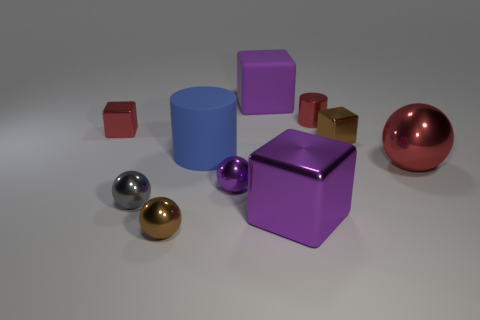Is the number of gray metal things that are to the left of the matte cylinder the same as the number of big metallic objects that are behind the tiny purple ball?
Offer a very short reply. Yes. There is a metal cube that is both behind the large blue object and in front of the small red metallic block; what is its color?
Your response must be concise. Brown. What is the material of the small cube that is to the right of the large purple block that is behind the large purple metal object?
Give a very brief answer. Metal. Does the matte cylinder have the same size as the red metal block?
Give a very brief answer. No. How many small things are red metallic cubes or purple matte things?
Offer a very short reply. 1. What number of small spheres are behind the big purple rubber cube?
Provide a short and direct response. 0. Is the number of big matte cylinders that are to the right of the tiny red cube greater than the number of big blue matte cylinders?
Provide a succinct answer. No. The small brown thing that is made of the same material as the small brown sphere is what shape?
Offer a very short reply. Cube. What is the color of the rubber object in front of the red metal object that is left of the large blue thing?
Offer a terse response. Blue. Is the gray metallic thing the same shape as the purple matte object?
Your answer should be very brief. No. 